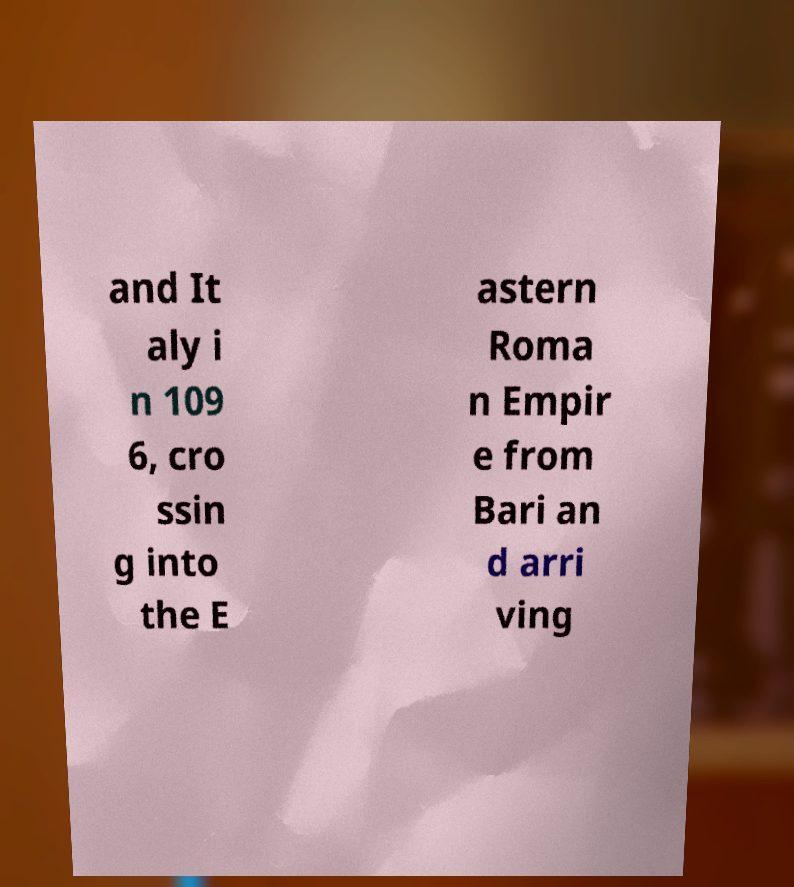Could you extract and type out the text from this image? and It aly i n 109 6, cro ssin g into the E astern Roma n Empir e from Bari an d arri ving 